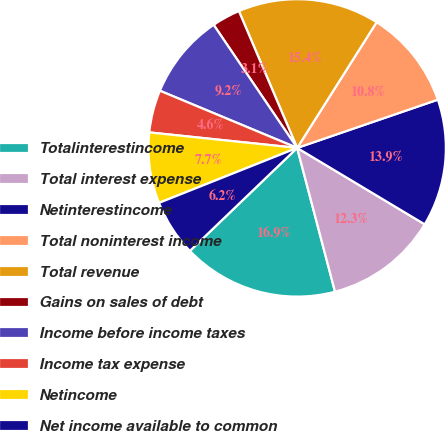Convert chart to OTSL. <chart><loc_0><loc_0><loc_500><loc_500><pie_chart><fcel>Totalinterestincome<fcel>Total interest expense<fcel>Netinterestincome<fcel>Total noninterest income<fcel>Total revenue<fcel>Gains on sales of debt<fcel>Income before income taxes<fcel>Income tax expense<fcel>Netincome<fcel>Net income available to common<nl><fcel>16.92%<fcel>12.31%<fcel>13.85%<fcel>10.77%<fcel>15.38%<fcel>3.08%<fcel>9.23%<fcel>4.62%<fcel>7.69%<fcel>6.15%<nl></chart> 